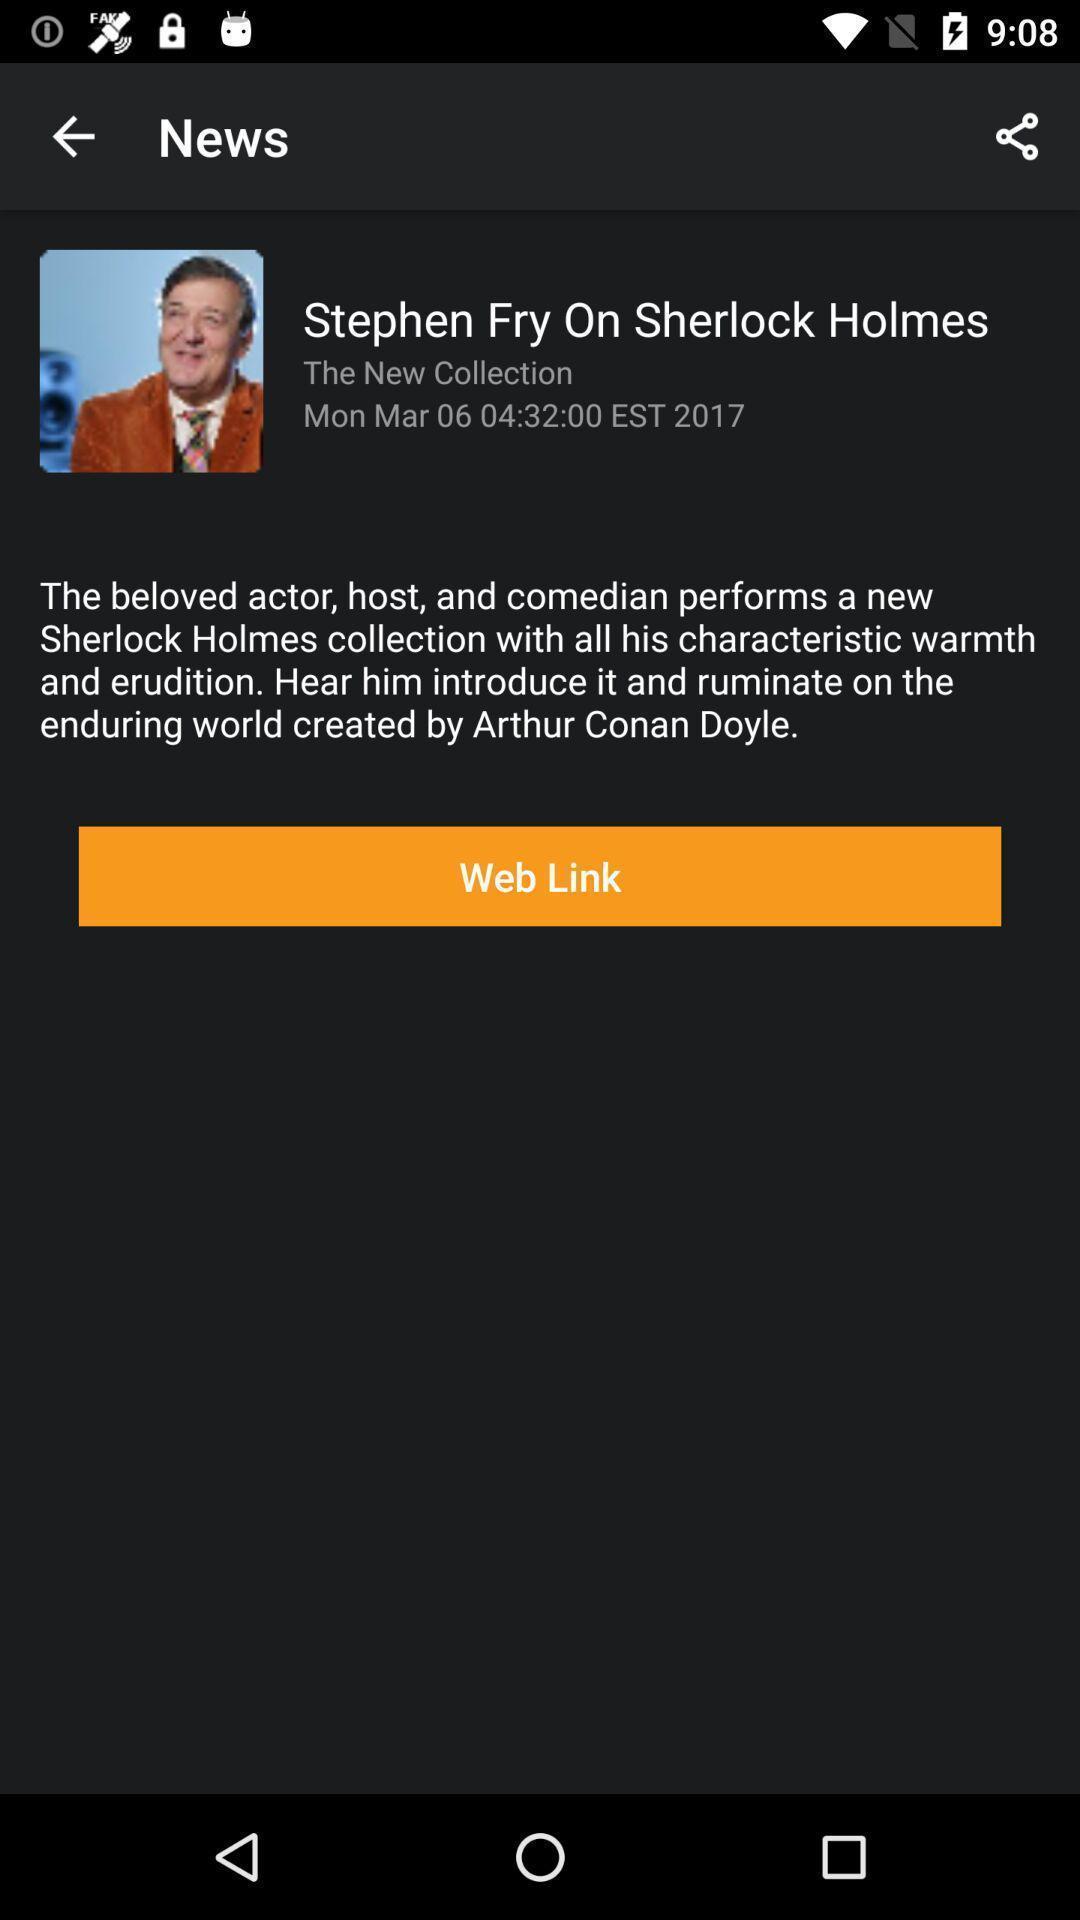What is the overall content of this screenshot? Page displaying information with share option. 